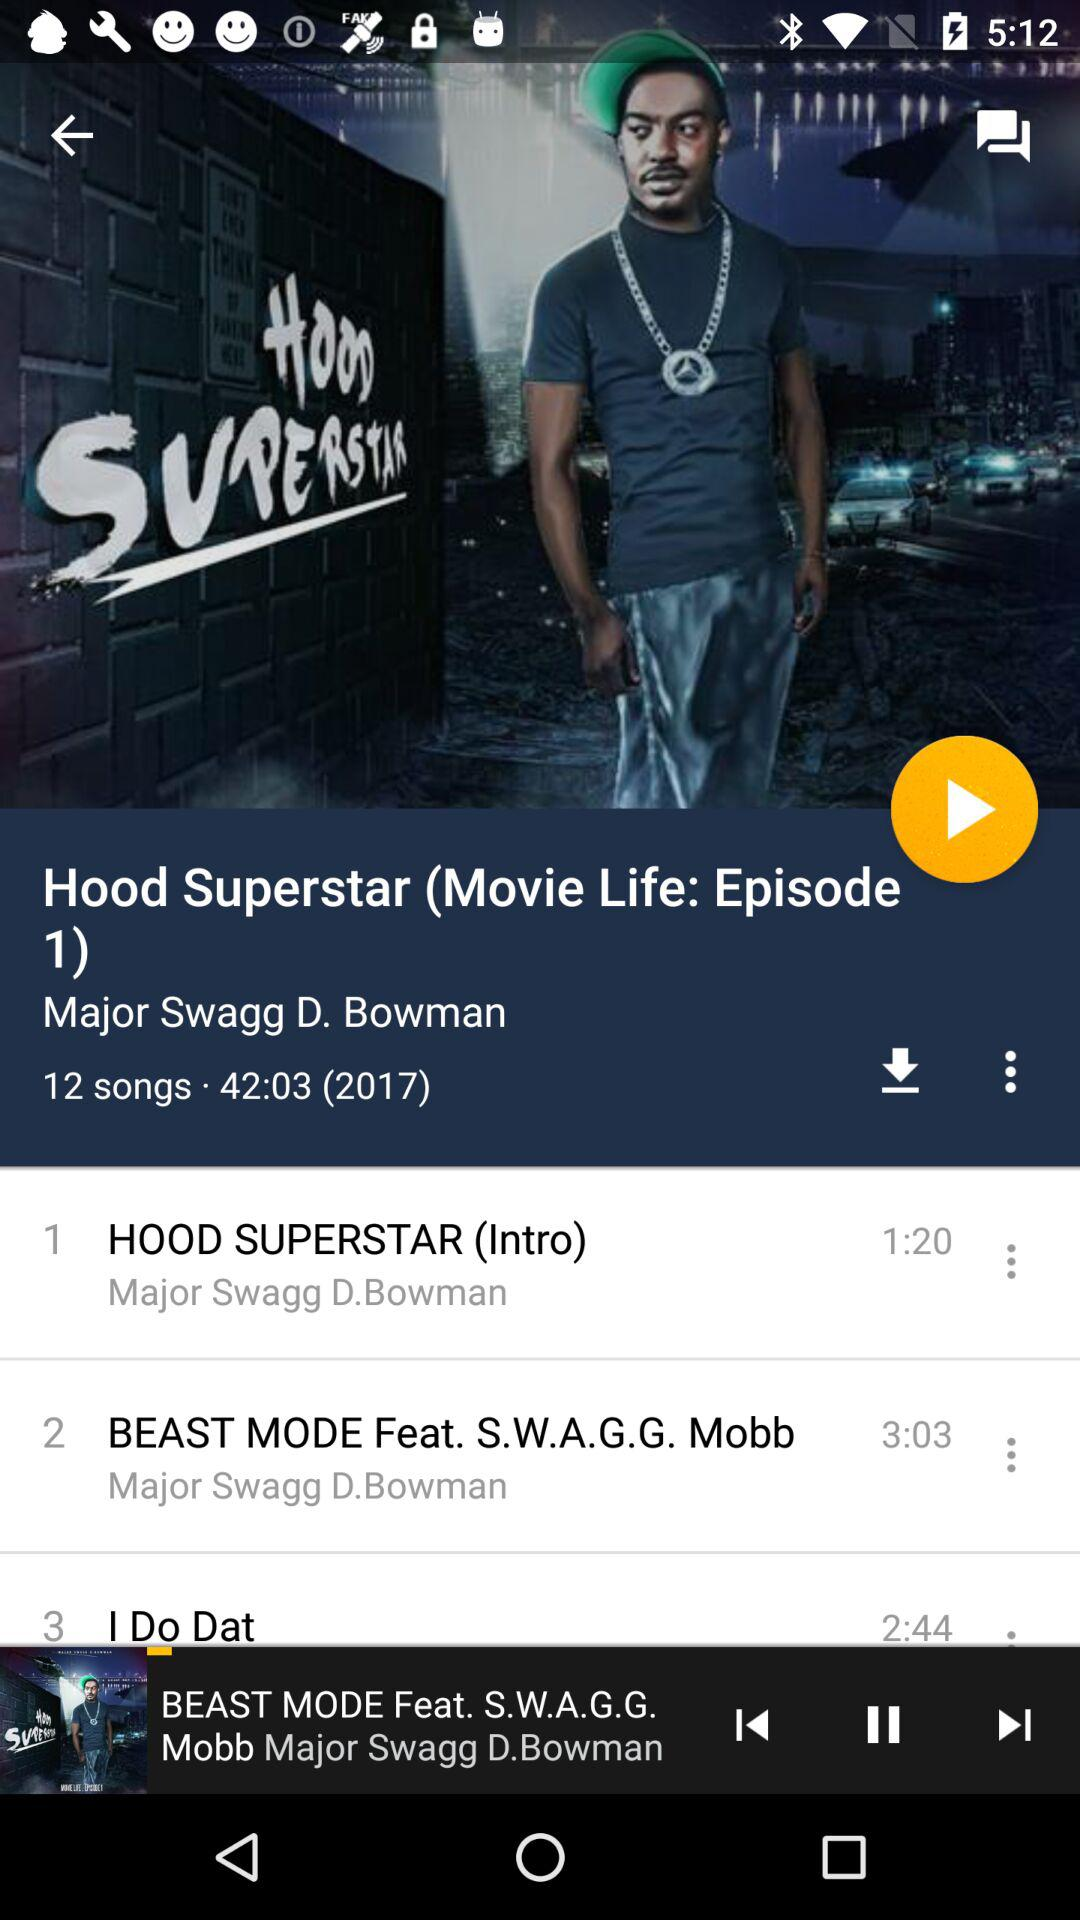What is the duration of beast mode? The duration is 3:03. 